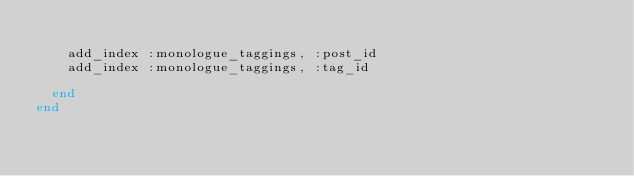<code> <loc_0><loc_0><loc_500><loc_500><_Ruby_>
    add_index :monologue_taggings, :post_id
    add_index :monologue_taggings, :tag_id

  end
end
</code> 